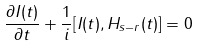Convert formula to latex. <formula><loc_0><loc_0><loc_500><loc_500>\frac { \partial I ( t ) } { \partial t } + \frac { 1 } { i } [ I ( t ) , H _ { s - r } ( t ) ] = 0</formula> 